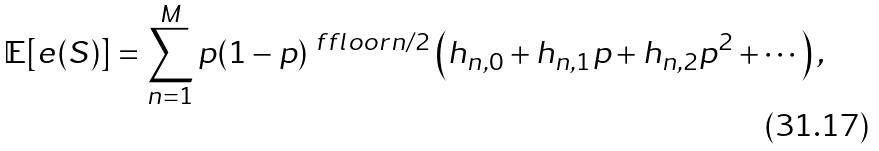<formula> <loc_0><loc_0><loc_500><loc_500>\mathbb { E } [ e ( S ) ] = \sum _ { n = 1 } ^ { M } p ( 1 - p ) ^ { \ f f l o o r { n / 2 } } \left ( h _ { n , 0 } + h _ { n , 1 } p + h _ { n , 2 } p ^ { 2 } + \cdots \right ) ,</formula> 